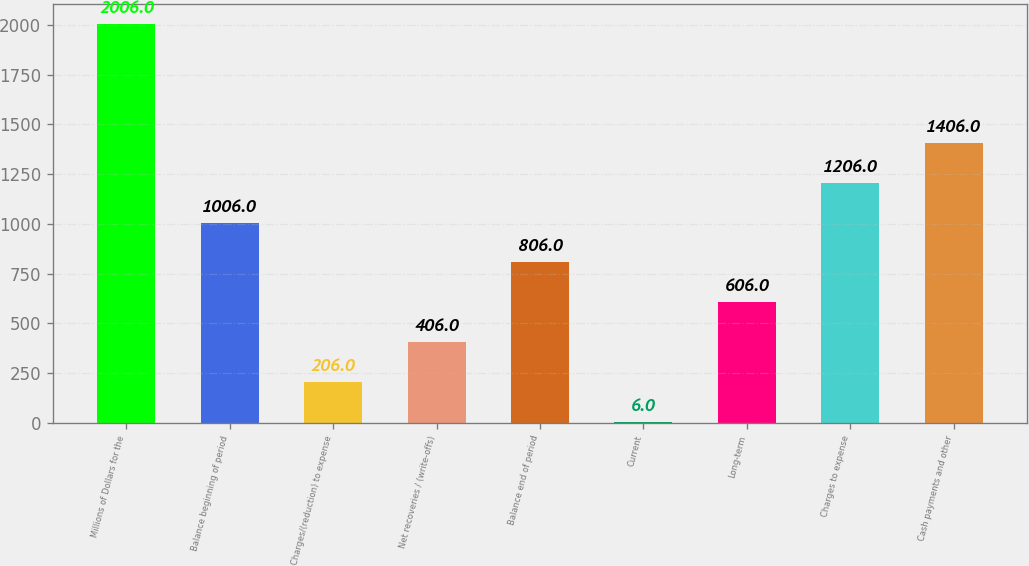Convert chart to OTSL. <chart><loc_0><loc_0><loc_500><loc_500><bar_chart><fcel>Millions of Dollars for the<fcel>Balance beginning of period<fcel>Charges/(reduction) to expense<fcel>Net recoveries / (write-offs)<fcel>Balance end of period<fcel>Current<fcel>Long-term<fcel>Charges to expense<fcel>Cash payments and other<nl><fcel>2006<fcel>1006<fcel>206<fcel>406<fcel>806<fcel>6<fcel>606<fcel>1206<fcel>1406<nl></chart> 